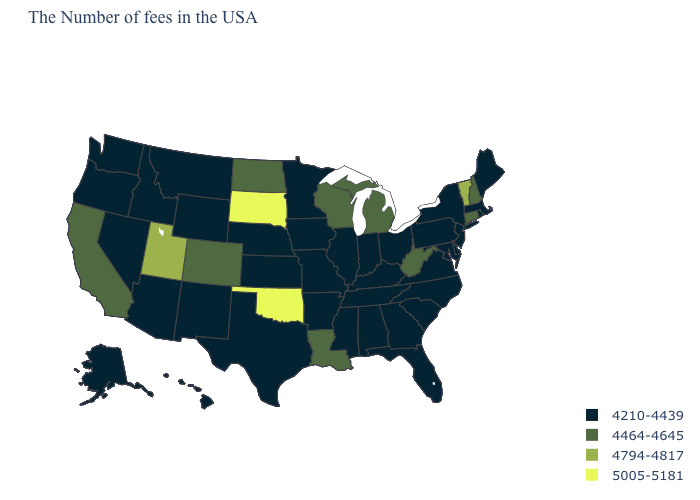What is the value of Kansas?
Quick response, please. 4210-4439. Does Ohio have the highest value in the MidWest?
Write a very short answer. No. Is the legend a continuous bar?
Keep it brief. No. Name the states that have a value in the range 4210-4439?
Give a very brief answer. Maine, Massachusetts, Rhode Island, New York, New Jersey, Delaware, Maryland, Pennsylvania, Virginia, North Carolina, South Carolina, Ohio, Florida, Georgia, Kentucky, Indiana, Alabama, Tennessee, Illinois, Mississippi, Missouri, Arkansas, Minnesota, Iowa, Kansas, Nebraska, Texas, Wyoming, New Mexico, Montana, Arizona, Idaho, Nevada, Washington, Oregon, Alaska, Hawaii. Does Nebraska have a lower value than Minnesota?
Short answer required. No. Does New Hampshire have a higher value than Hawaii?
Write a very short answer. Yes. Among the states that border South Dakota , does North Dakota have the highest value?
Be succinct. Yes. What is the highest value in the USA?
Give a very brief answer. 5005-5181. Does Oklahoma have a lower value than Maine?
Write a very short answer. No. Does New Mexico have the highest value in the USA?
Be succinct. No. Name the states that have a value in the range 4794-4817?
Quick response, please. Vermont, Utah. Among the states that border Rhode Island , which have the lowest value?
Write a very short answer. Massachusetts. What is the highest value in the West ?
Short answer required. 4794-4817. What is the highest value in the USA?
Concise answer only. 5005-5181. 